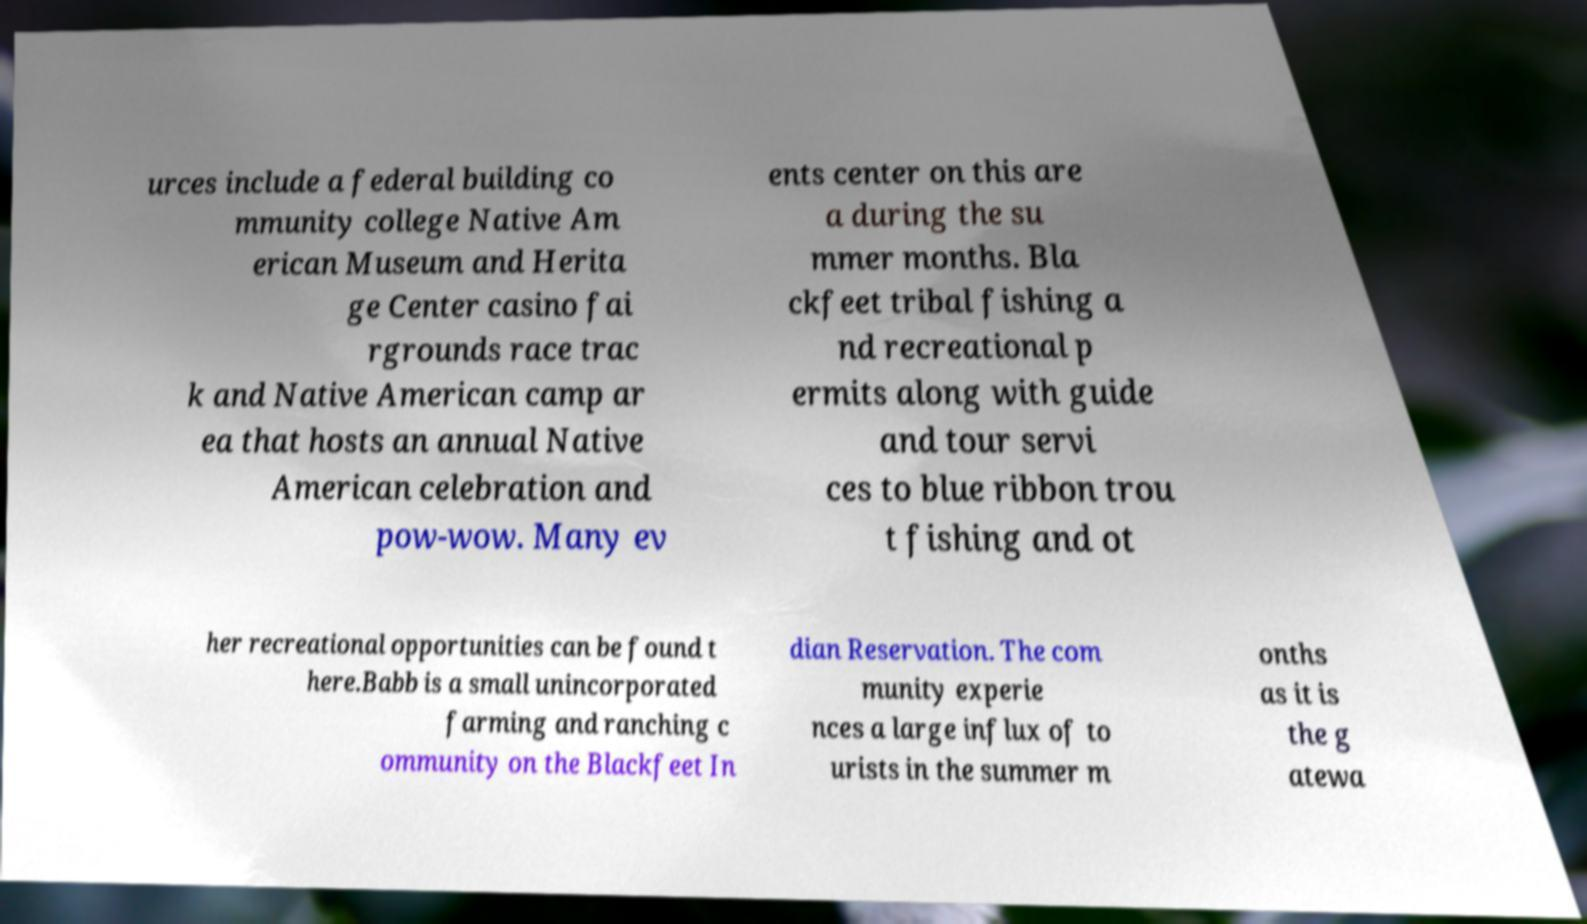Can you accurately transcribe the text from the provided image for me? urces include a federal building co mmunity college Native Am erican Museum and Herita ge Center casino fai rgrounds race trac k and Native American camp ar ea that hosts an annual Native American celebration and pow-wow. Many ev ents center on this are a during the su mmer months. Bla ckfeet tribal fishing a nd recreational p ermits along with guide and tour servi ces to blue ribbon trou t fishing and ot her recreational opportunities can be found t here.Babb is a small unincorporated farming and ranching c ommunity on the Blackfeet In dian Reservation. The com munity experie nces a large influx of to urists in the summer m onths as it is the g atewa 